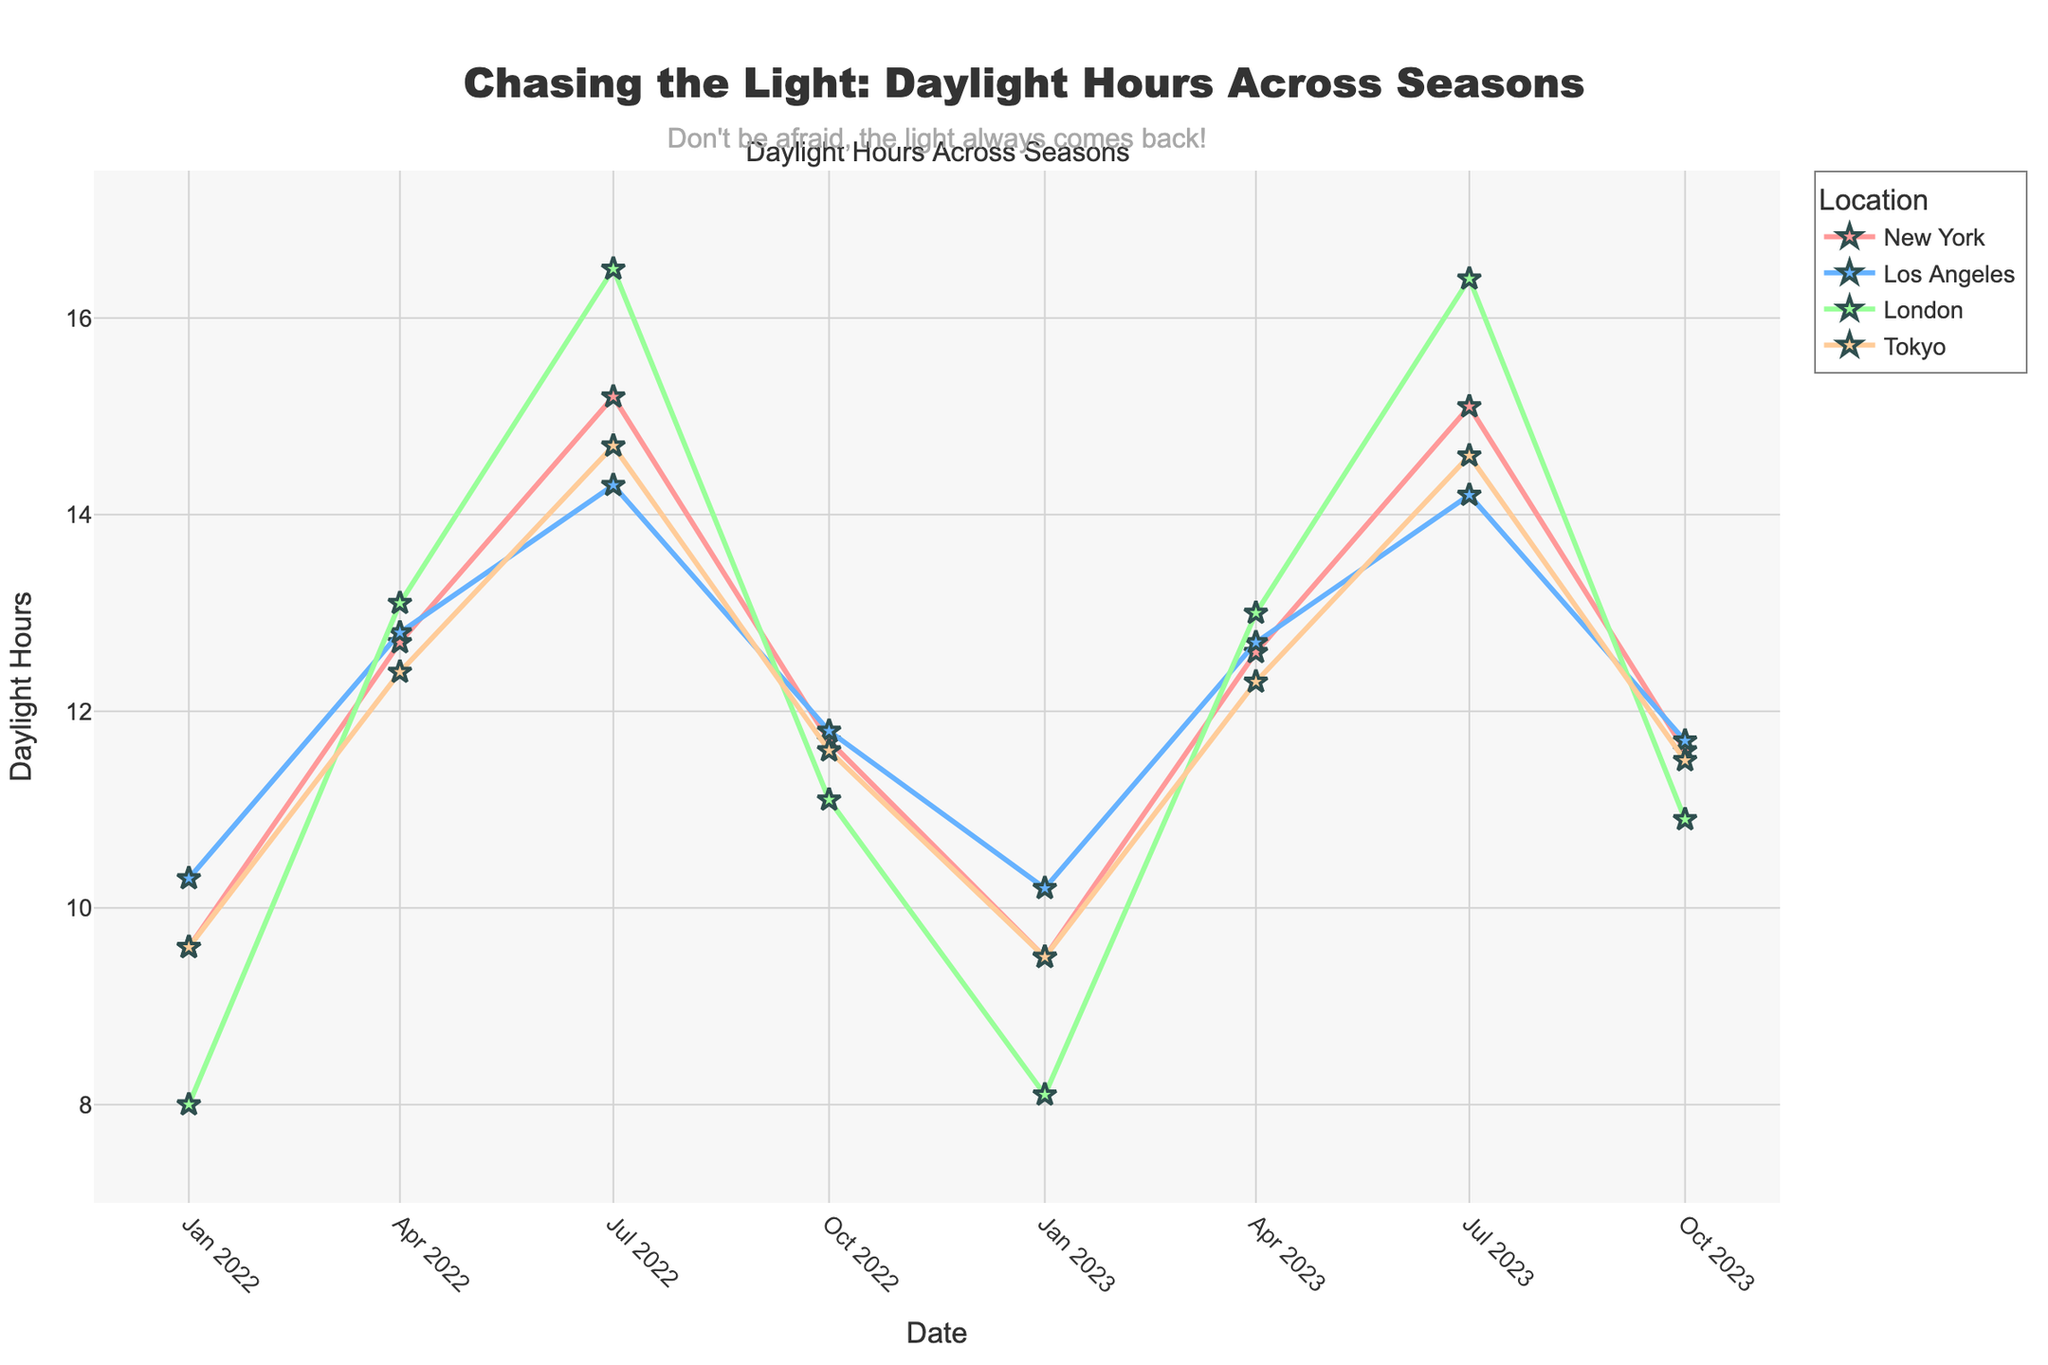What's the title of the plot? The title can be found at the top of the plot, it usually gives an overview of what the plot is about in natural language.
Answer: Chasing the Light: Daylight Hours Across Seasons What is the duration of daylight hours in New York on January 1st, 2022? Locate the date "January 1st, 2022" on the x-axis, and then find the corresponding line marker for New York to read the daylight hours value.
Answer: 9.6 hours Which location had the longest daylight hours on July 1st, 2022? Look at the x-axis for the date "July 1st, 2022" and compare the y-values of each location. The highest y-value indicates the location with the longest daylight hours.
Answer: London How does the daylight duration in London compare between January 1st, 2022, and July 1st, 2022? Find the daylight hours for London on both dates by checking the y-axis values. Then determine the difference.
Answer: 8.0 hours on January 1st, 2022, and 16.5 hours on July 1st, 2022 Which location shows a near consistent daylight hour across the seasons? Look for a line that shows the least fluctuation (i.e., the most horizontal line).
Answer: Los Angeles How much does the daylight duration in Tokyo change from January to July 2022? Identify the daylight hours in Tokyo for both dates and calculate the difference between the two.
Answer: 14.7 - 9.6 = 5.1 hours Which location had the least daylight hours on October 1st, 2023? Look at the x-axis for the date "October 1st, 2023," and find the location with the lowest y-value.
Answer: London By how much did the daylight duration in New York decrease between July 1st and October 1st in 2022? Compare the daylight hours for New York on these two dates and subtract the October value from the July value.
Answer: 15.2 - 11.7 = 3.5 hours Is there any location that shows an increase in daylight hours between January and October? Examine the four plotted lines and check if any of them have a higher y-value in October than in January.
Answer: No What is the general trend of daylight hours across seasons for all locations? Observe the plotted lines for all locations across the different dates. Notice if there is a common pattern such as increasing toward the middle of the year and decreasing toward the ends.
Answer: Increases towards mid-year (July) and decreases towards the start and end of the year 